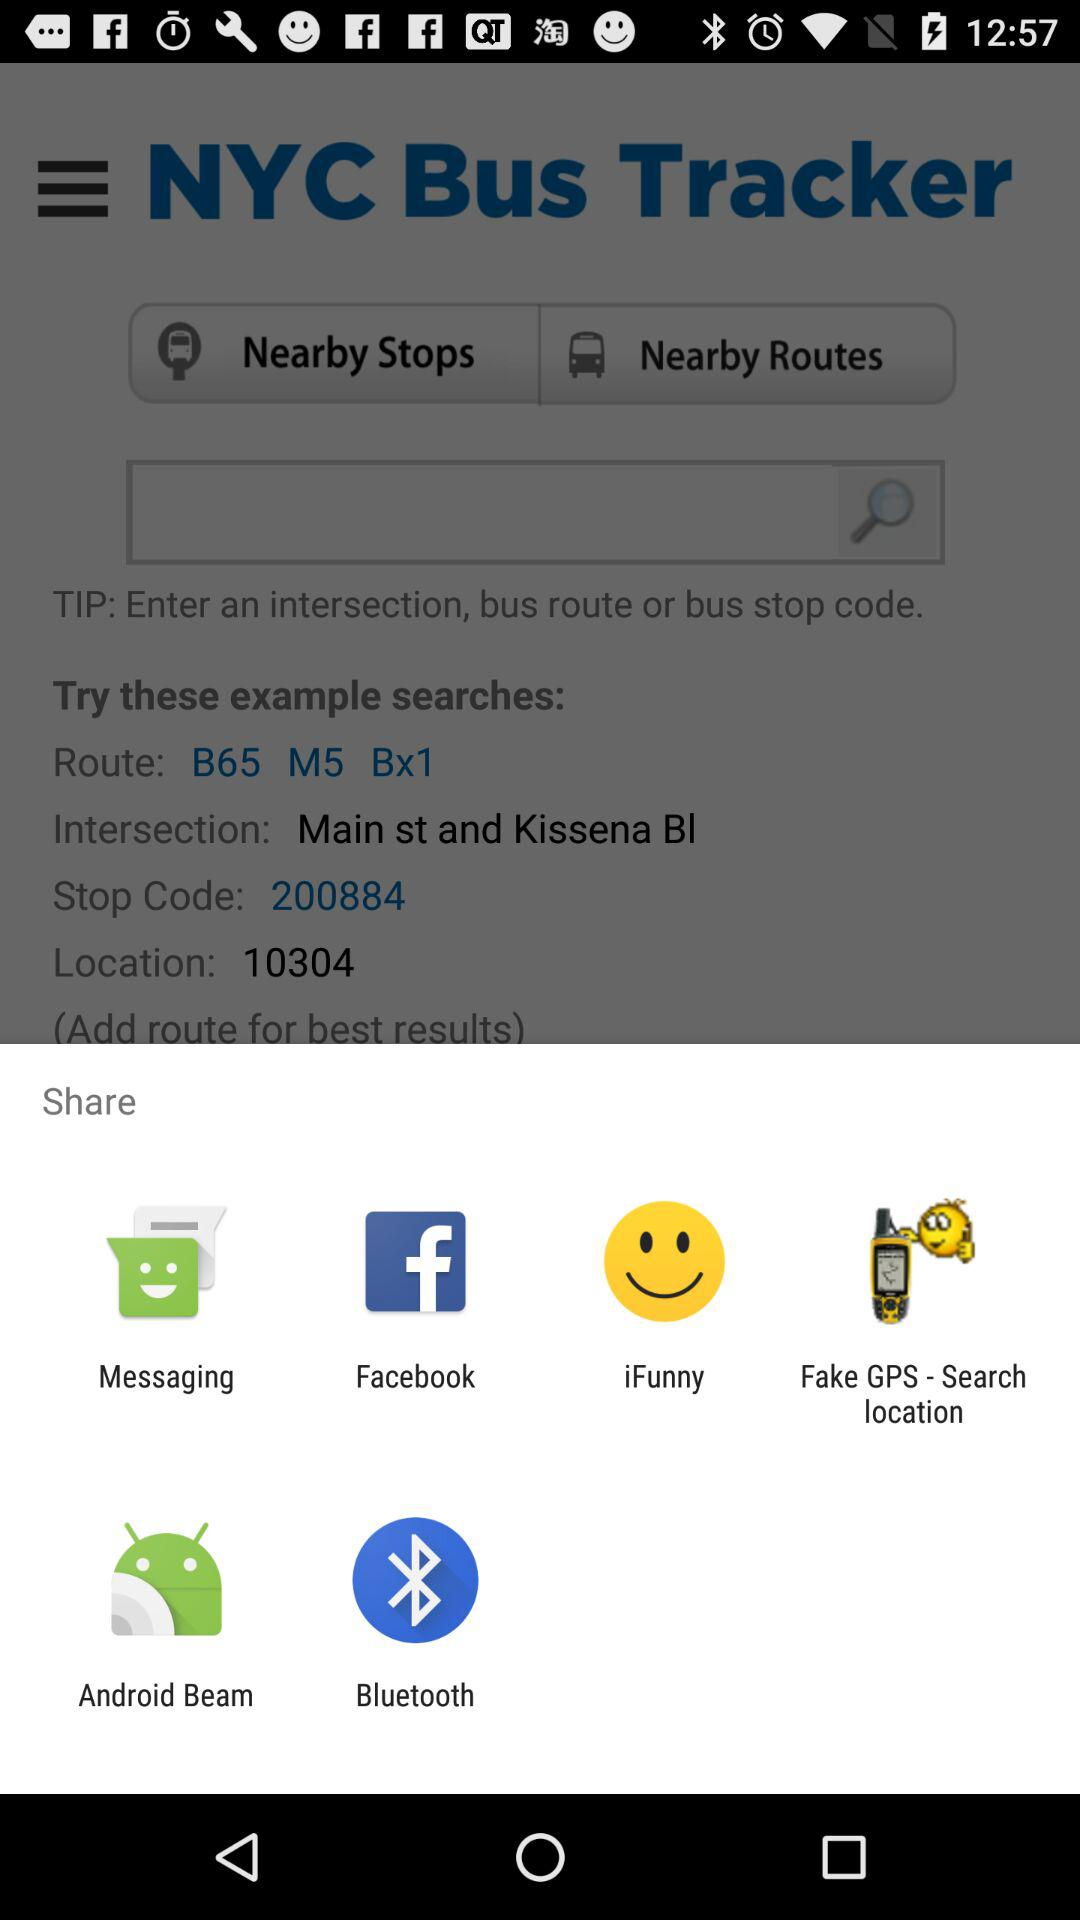Through which application can we share the bus tracker? You can share it through "Messaging", "Facebook", "iFunny", "Fake GPS - Search location", "Android Beam" and "Bluetooth". 